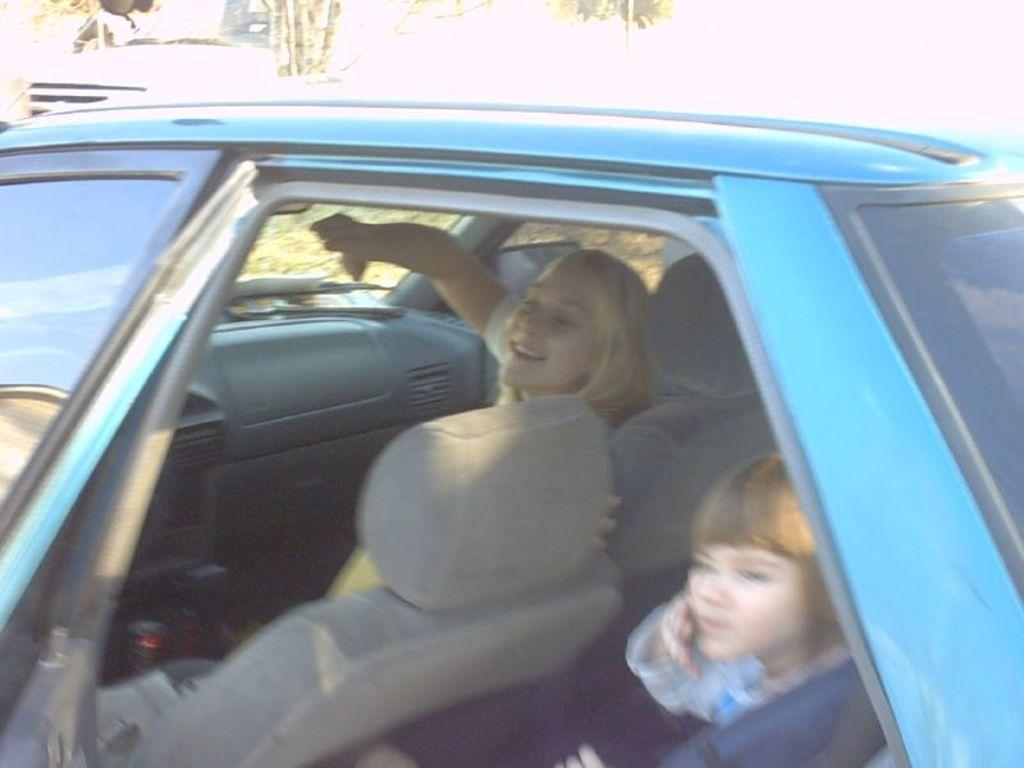What is the main subject of the image? The main subject of the image is a car. Who is inside the car? There is a woman sitting in the front of the car and a girl sitting in the back of the car. What is the woman doing in the image? The woman is smiling. What is the girl doing in the image? The girl is looking outside the window. What type of plant can be seen growing in the car in the image? There is no plant visible in the car in the image. Can you tell me how many men are present in the image? There is no man present in the image; it features a woman and a girl. 